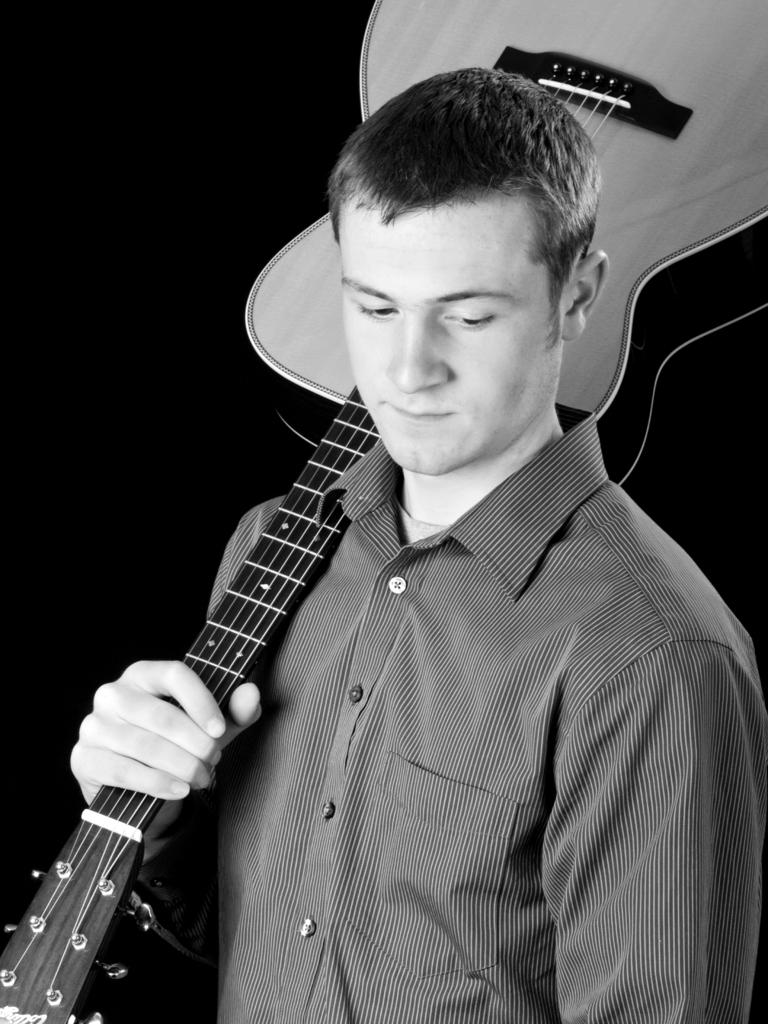What is present in the image? There is a person in the image. Can you describe what the person is wearing? The person is wearing a shirt. What is the person holding in the image? The person is holding a guitar on his shoulder. What type of mark can be seen on the person's face in the image? There is no mark visible on the person's face in the image. Is the person holding a ball in the image? No, the person is not holding a ball in the image; they are holding a guitar. --- Facts: 1. There is a person in the image. 2. The person is wearing a hat. 3. The person is holding a book. 4. There is a table in the image. Absurd Topics: dance, ocean, rainbow Conversation: What is present in the image? There is a person in the image. Can you describe what the person is wearing? The person is wearing a hat. What is the person holding in the image? The person is holding a book. What type of furniture is visible in the image? There is a table in the image. Reasoning: Let's think step by step in order to produce the conversation. We start by identifying the main subject in the image, which is the person. Then, we expand the conversation to include the person's clothing and the object they are holding, which is a book. Finally, we mention the presence of a table in the image. Each question is designed to elicit a specific detail about the image that is known from the provided facts. Absurd Question/Answer: Can you see the person dancing in the image? No, the person is not dancing in the image; they are holding a book. Is the person standing near the ocean in the image? No, there is no ocean visible in the image. Can you see a rainbow in the image? No, there is no rainbow present in the image. 